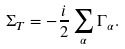Convert formula to latex. <formula><loc_0><loc_0><loc_500><loc_500>\Sigma _ { T } = - \frac { i } { 2 } \sum _ { \alpha } \Gamma _ { \alpha } .</formula> 